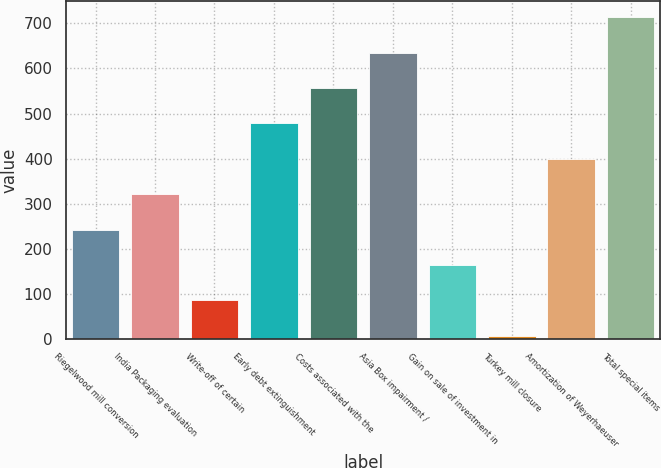Convert chart to OTSL. <chart><loc_0><loc_0><loc_500><loc_500><bar_chart><fcel>Riegelwood mill conversion<fcel>India Packaging evaluation<fcel>Write-off of certain<fcel>Early debt extinguishment<fcel>Costs associated with the<fcel>Asia Box impairment /<fcel>Gain on sale of investment in<fcel>Turkey mill closure<fcel>Amortization of Weyerhaeuser<fcel>Total special items<nl><fcel>242.5<fcel>321<fcel>85.5<fcel>478<fcel>556.5<fcel>635<fcel>164<fcel>7<fcel>399.5<fcel>713.5<nl></chart> 